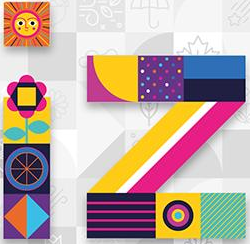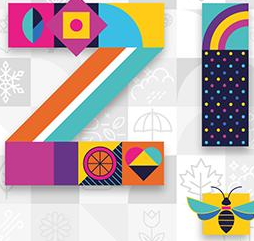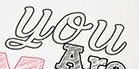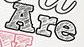What text is displayed in these images sequentially, separated by a semicolon? iz; iz; You; Are 